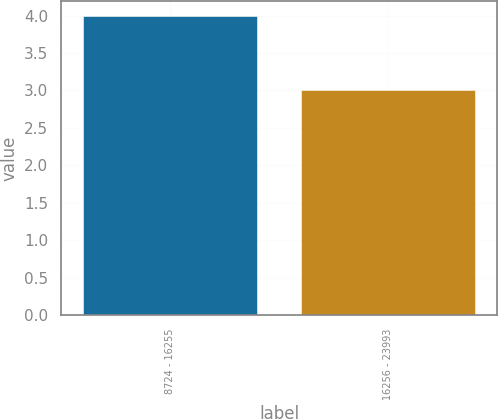<chart> <loc_0><loc_0><loc_500><loc_500><bar_chart><fcel>8724 - 16255<fcel>16256 - 23993<nl><fcel>4<fcel>3<nl></chart> 